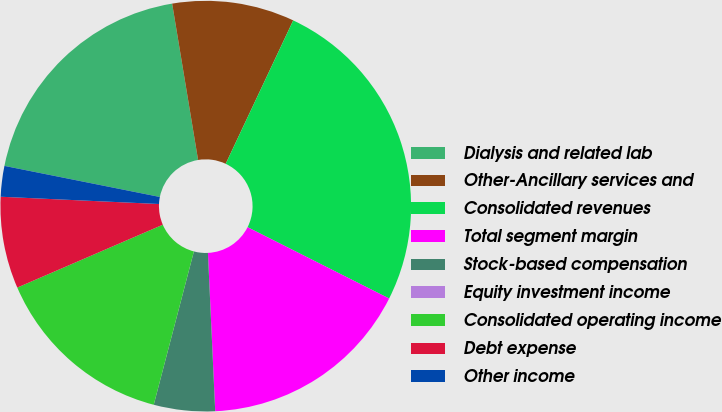<chart> <loc_0><loc_0><loc_500><loc_500><pie_chart><fcel>Dialysis and related lab<fcel>Other-Ancillary services and<fcel>Consolidated revenues<fcel>Total segment margin<fcel>Stock-based compensation<fcel>Equity investment income<fcel>Consolidated operating income<fcel>Debt expense<fcel>Other income<nl><fcel>19.24%<fcel>9.62%<fcel>25.42%<fcel>16.84%<fcel>4.81%<fcel>0.0%<fcel>14.43%<fcel>7.22%<fcel>2.41%<nl></chart> 